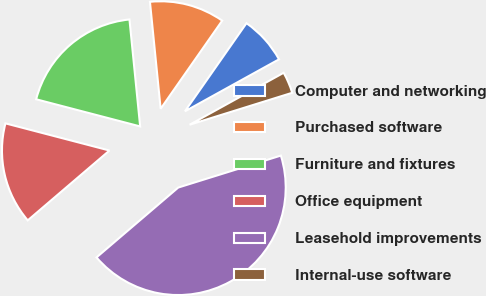Convert chart to OTSL. <chart><loc_0><loc_0><loc_500><loc_500><pie_chart><fcel>Computer and networking<fcel>Purchased software<fcel>Furniture and fixtures<fcel>Office equipment<fcel>Leasehold improvements<fcel>Internal-use software<nl><fcel>7.26%<fcel>11.29%<fcel>19.35%<fcel>15.32%<fcel>43.55%<fcel>3.23%<nl></chart> 